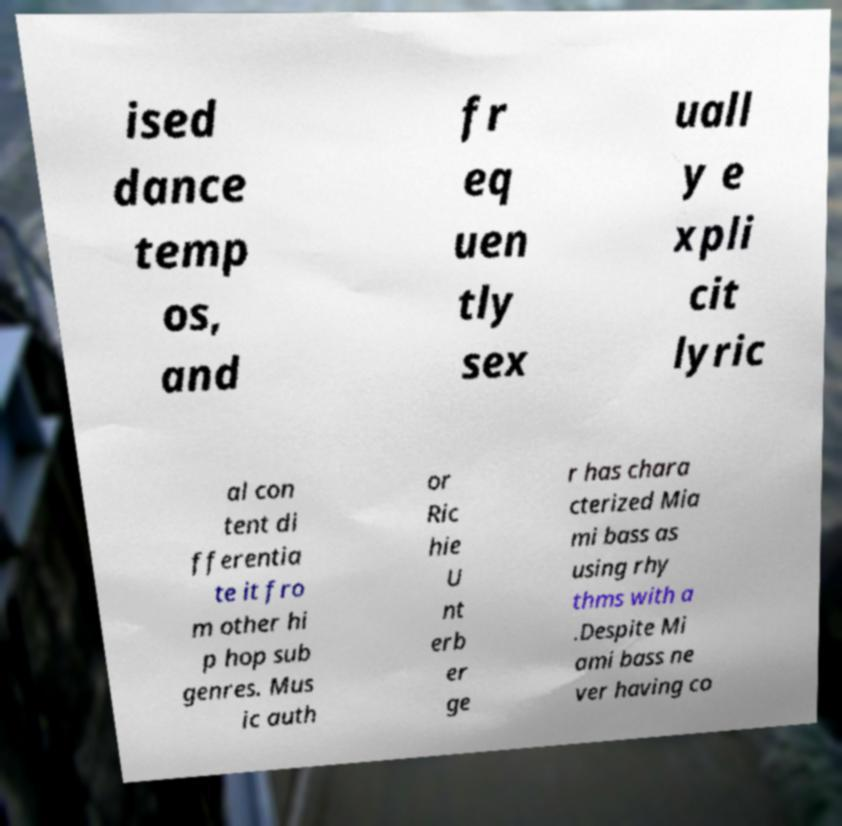There's text embedded in this image that I need extracted. Can you transcribe it verbatim? ised dance temp os, and fr eq uen tly sex uall y e xpli cit lyric al con tent di fferentia te it fro m other hi p hop sub genres. Mus ic auth or Ric hie U nt erb er ge r has chara cterized Mia mi bass as using rhy thms with a .Despite Mi ami bass ne ver having co 